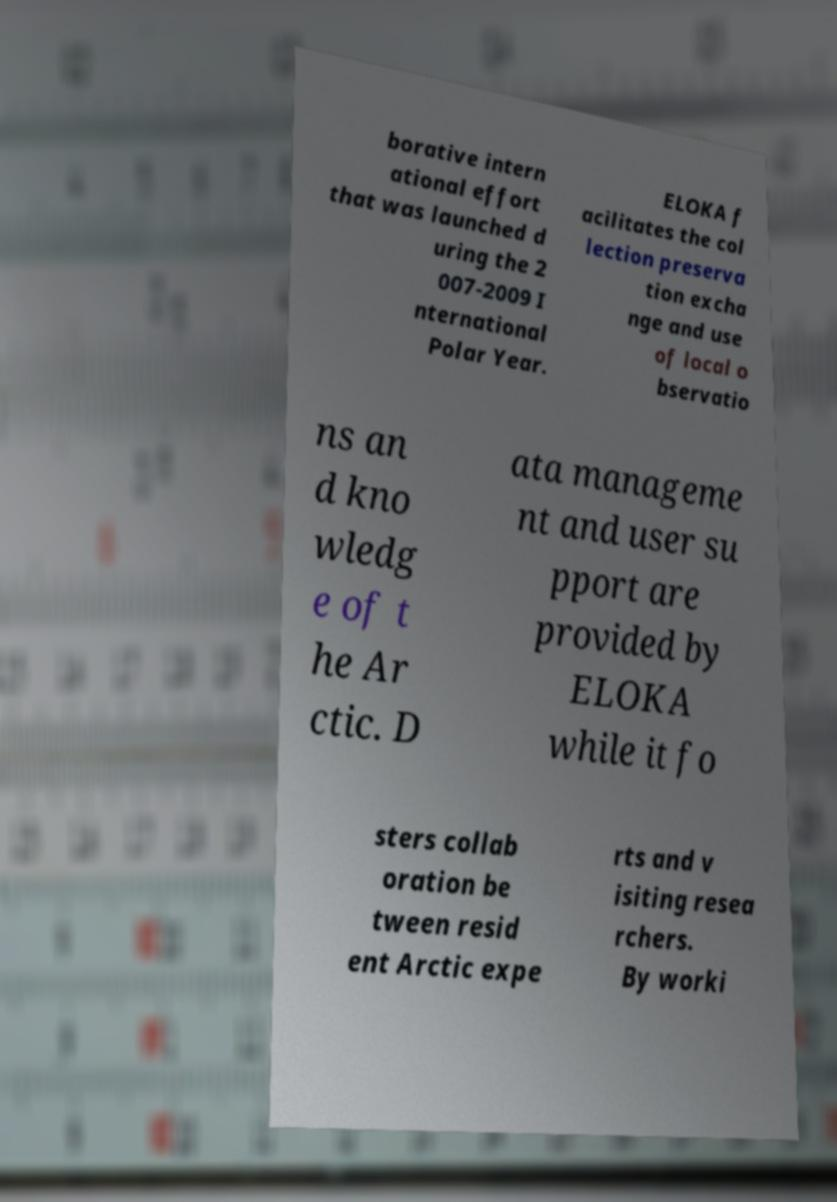Please read and relay the text visible in this image. What does it say? borative intern ational effort that was launched d uring the 2 007-2009 I nternational Polar Year. ELOKA f acilitates the col lection preserva tion excha nge and use of local o bservatio ns an d kno wledg e of t he Ar ctic. D ata manageme nt and user su pport are provided by ELOKA while it fo sters collab oration be tween resid ent Arctic expe rts and v isiting resea rchers. By worki 